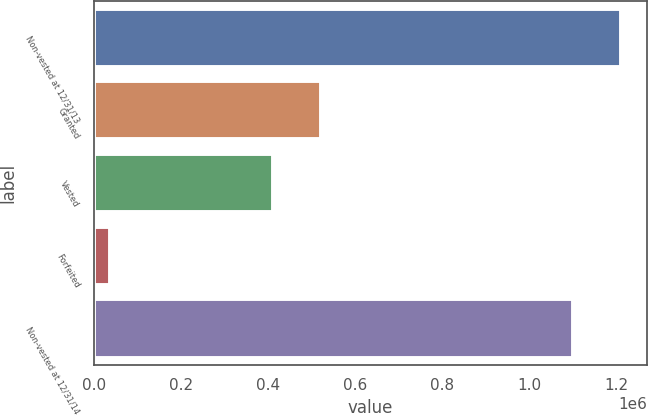Convert chart to OTSL. <chart><loc_0><loc_0><loc_500><loc_500><bar_chart><fcel>Non-vested at 12/31/13<fcel>Granted<fcel>Vested<fcel>Forfeited<fcel>Non-vested at 12/31/14<nl><fcel>1.20901e+06<fcel>520104<fcel>411704<fcel>37597<fcel>1.10061e+06<nl></chart> 